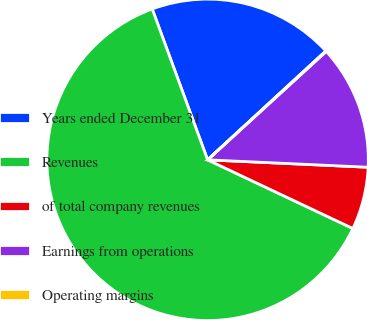Convert chart to OTSL. <chart><loc_0><loc_0><loc_500><loc_500><pie_chart><fcel>Years ended December 31<fcel>Revenues<fcel>of total company revenues<fcel>Earnings from operations<fcel>Operating margins<nl><fcel>18.75%<fcel>62.36%<fcel>6.29%<fcel>12.52%<fcel>0.06%<nl></chart> 